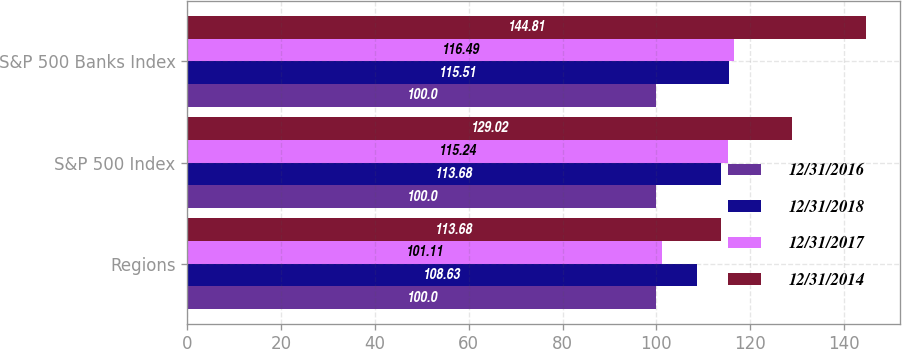Convert chart to OTSL. <chart><loc_0><loc_0><loc_500><loc_500><stacked_bar_chart><ecel><fcel>Regions<fcel>S&P 500 Index<fcel>S&P 500 Banks Index<nl><fcel>12/31/2016<fcel>100<fcel>100<fcel>100<nl><fcel>12/31/2018<fcel>108.63<fcel>113.68<fcel>115.51<nl><fcel>12/31/2017<fcel>101.11<fcel>115.24<fcel>116.49<nl><fcel>12/31/2014<fcel>113.68<fcel>129.02<fcel>144.81<nl></chart> 